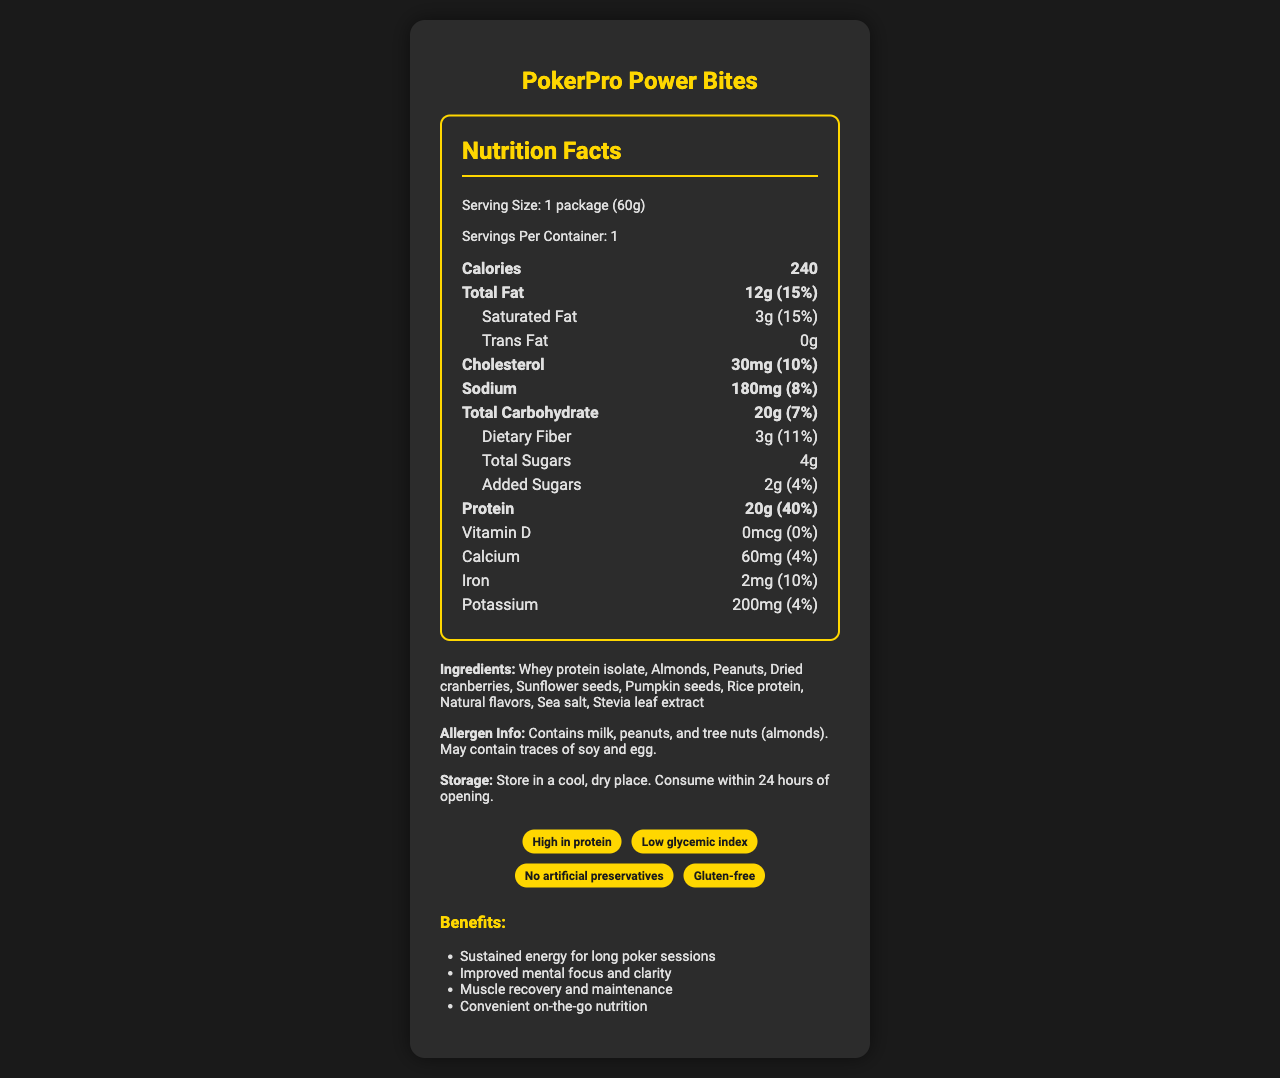what is the serving size of PokerPro Power Bites? The serving size is clearly stated in the serving information section.
Answer: 1 package (60g) how many total calories are in one package? The number of total calories is explicitly listed at the top of the nutrition facts.
Answer: 240 how many grams of protein are there in one serving? The amount of protein per serving, along with its daily value percentage, is clearly specified in the nutrition facts.
Answer: 20g what types of nuts are included in the ingredient list? The ingredient list includes "Almonds" and "Peanuts."
Answer: Almonds and Peanuts how much sugar is added to the product? The amount of added sugars is specified in the nutrition facts.
Answer: 2g what percentage of the daily value of iron is met by consuming this product? The daily value percentage for iron is listed as 10% in the nutrition facts.
Answer: 10% which of the following ingredients is not included in PokerPro Power Bites? A. Stevia leaf extract B. Peanuts C. Soy D. Dried cranberries All listed ingredients except soy are included in the ingredient list provided.
Answer: C what are some of the health benefits of consuming PokerPro Power Bites? A. Improved skin health B. Sustained energy C. Reduced cholesterol levels D. Muscle recovery The benefits listed include "Sustained energy for long poker sessions" and "Muscle recovery and maintenance."
Answer: B, D is this product gluten-free? The claim section states "Gluten-free" as one of the claims.
Answer: Yes describe the main idea of this document. The document is structured to give a comprehensive understanding of the nutritional value and benefits of PokerPro Power Bites, focusing on its high protein content and other health claims for poker players.
Answer: The document provides a detailed overview of the nutrition facts, ingredients, allergen information, benefits, and claims of the PokerPro Power Bites protein-rich snack. It emphasizes the high protein content, lack of artificial preservatives, and suitability for maintaining energy and focus during long poker sessions. what is the manufacturing location of PokerPro Power Bites? The document mentions the headquarters of PokerPro Nutrition in Las Vegas, NV, but it does not specify the exact manufacturing location.
Answer: Cannot be determined 